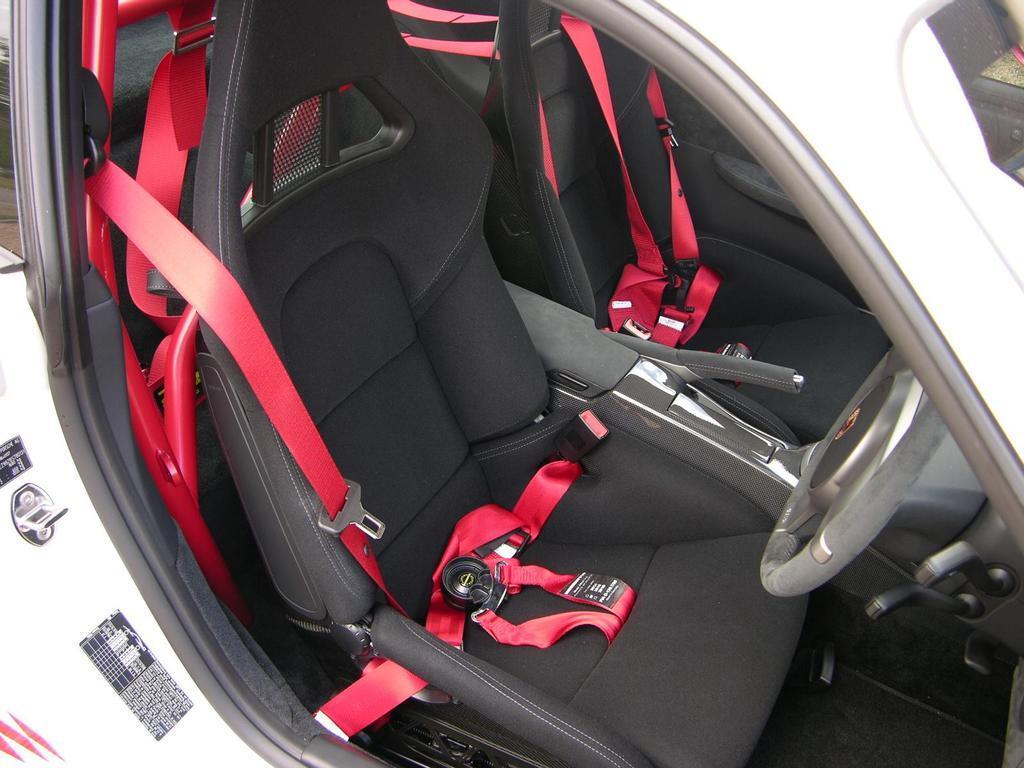How would you summarize this image in a sentence or two? In the image i can see the inside of the car and i also see the red belts in the car. 